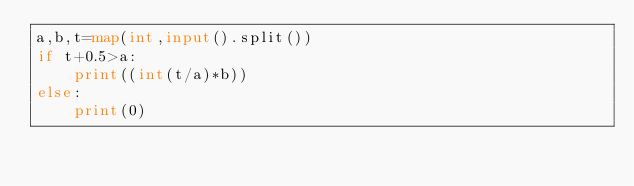<code> <loc_0><loc_0><loc_500><loc_500><_Python_>a,b,t=map(int,input().split())
if t+0.5>a:
    print((int(t/a)*b))
else:
    print(0)</code> 